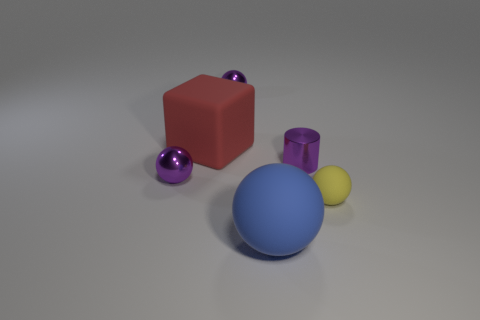Subtract all small rubber balls. How many balls are left? 3 Add 2 small purple metal spheres. How many objects exist? 8 Subtract all blue balls. How many balls are left? 3 Add 5 yellow metallic balls. How many yellow metallic balls exist? 5 Subtract 0 brown blocks. How many objects are left? 6 Subtract all balls. How many objects are left? 2 Subtract 1 cubes. How many cubes are left? 0 Subtract all yellow cylinders. Subtract all yellow balls. How many cylinders are left? 1 Subtract all cyan blocks. How many blue spheres are left? 1 Subtract all gray metallic objects. Subtract all purple metal spheres. How many objects are left? 4 